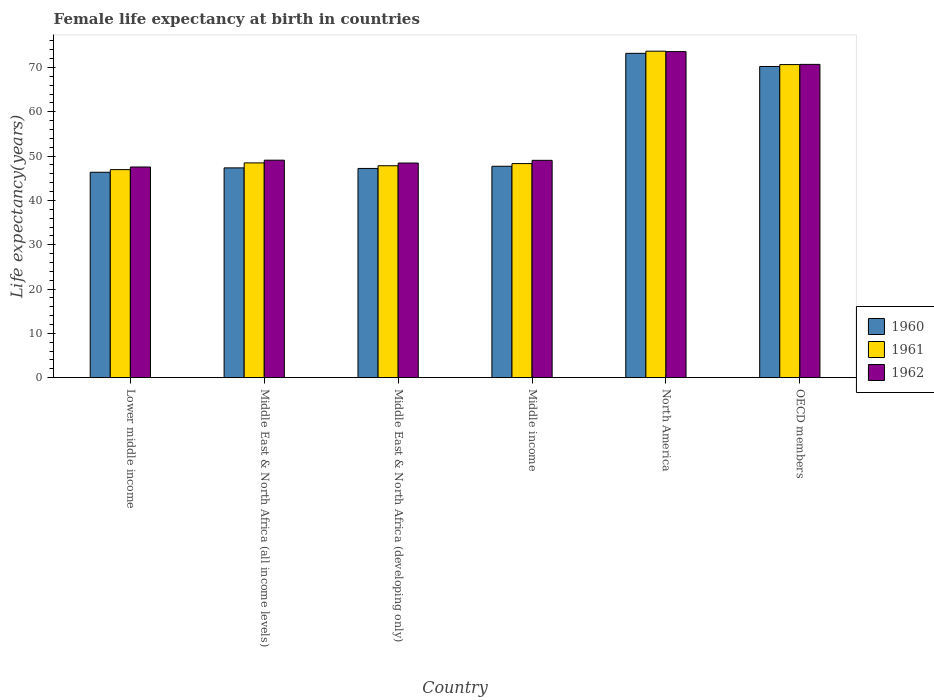How many different coloured bars are there?
Ensure brevity in your answer.  3. How many bars are there on the 3rd tick from the left?
Ensure brevity in your answer.  3. What is the female life expectancy at birth in 1960 in Middle income?
Provide a succinct answer. 47.7. Across all countries, what is the maximum female life expectancy at birth in 1962?
Provide a succinct answer. 73.58. Across all countries, what is the minimum female life expectancy at birth in 1961?
Offer a very short reply. 46.95. In which country was the female life expectancy at birth in 1960 maximum?
Your answer should be compact. North America. In which country was the female life expectancy at birth in 1960 minimum?
Provide a short and direct response. Lower middle income. What is the total female life expectancy at birth in 1961 in the graph?
Ensure brevity in your answer.  335.88. What is the difference between the female life expectancy at birth in 1961 in Lower middle income and that in Middle East & North Africa (developing only)?
Offer a terse response. -0.87. What is the difference between the female life expectancy at birth in 1961 in Middle East & North Africa (developing only) and the female life expectancy at birth in 1960 in OECD members?
Provide a succinct answer. -22.41. What is the average female life expectancy at birth in 1961 per country?
Give a very brief answer. 55.98. What is the difference between the female life expectancy at birth of/in 1961 and female life expectancy at birth of/in 1960 in OECD members?
Ensure brevity in your answer.  0.42. In how many countries, is the female life expectancy at birth in 1962 greater than 70 years?
Your response must be concise. 2. What is the ratio of the female life expectancy at birth in 1961 in Middle East & North Africa (all income levels) to that in Middle East & North Africa (developing only)?
Keep it short and to the point. 1.01. Is the difference between the female life expectancy at birth in 1961 in Middle East & North Africa (all income levels) and OECD members greater than the difference between the female life expectancy at birth in 1960 in Middle East & North Africa (all income levels) and OECD members?
Your answer should be very brief. Yes. What is the difference between the highest and the second highest female life expectancy at birth in 1961?
Your response must be concise. -25.21. What is the difference between the highest and the lowest female life expectancy at birth in 1960?
Make the answer very short. 26.84. Are all the bars in the graph horizontal?
Your answer should be very brief. No. Does the graph contain any zero values?
Your answer should be very brief. No. Does the graph contain grids?
Your answer should be very brief. No. How many legend labels are there?
Provide a short and direct response. 3. How are the legend labels stacked?
Provide a succinct answer. Vertical. What is the title of the graph?
Make the answer very short. Female life expectancy at birth in countries. What is the label or title of the Y-axis?
Offer a very short reply. Life expectancy(years). What is the Life expectancy(years) of 1960 in Lower middle income?
Offer a terse response. 46.36. What is the Life expectancy(years) of 1961 in Lower middle income?
Give a very brief answer. 46.95. What is the Life expectancy(years) of 1962 in Lower middle income?
Ensure brevity in your answer.  47.54. What is the Life expectancy(years) of 1960 in Middle East & North Africa (all income levels)?
Ensure brevity in your answer.  47.34. What is the Life expectancy(years) in 1961 in Middle East & North Africa (all income levels)?
Your response must be concise. 48.47. What is the Life expectancy(years) of 1962 in Middle East & North Africa (all income levels)?
Provide a succinct answer. 49.08. What is the Life expectancy(years) in 1960 in Middle East & North Africa (developing only)?
Provide a short and direct response. 47.21. What is the Life expectancy(years) of 1961 in Middle East & North Africa (developing only)?
Make the answer very short. 47.82. What is the Life expectancy(years) in 1962 in Middle East & North Africa (developing only)?
Your answer should be compact. 48.44. What is the Life expectancy(years) in 1960 in Middle income?
Make the answer very short. 47.7. What is the Life expectancy(years) of 1961 in Middle income?
Give a very brief answer. 48.31. What is the Life expectancy(years) of 1962 in Middle income?
Your response must be concise. 49.05. What is the Life expectancy(years) in 1960 in North America?
Your answer should be very brief. 73.19. What is the Life expectancy(years) in 1961 in North America?
Your answer should be compact. 73.68. What is the Life expectancy(years) of 1962 in North America?
Your response must be concise. 73.58. What is the Life expectancy(years) in 1960 in OECD members?
Your answer should be very brief. 70.23. What is the Life expectancy(years) in 1961 in OECD members?
Offer a terse response. 70.65. What is the Life expectancy(years) of 1962 in OECD members?
Ensure brevity in your answer.  70.7. Across all countries, what is the maximum Life expectancy(years) in 1960?
Provide a succinct answer. 73.19. Across all countries, what is the maximum Life expectancy(years) of 1961?
Ensure brevity in your answer.  73.68. Across all countries, what is the maximum Life expectancy(years) of 1962?
Provide a short and direct response. 73.58. Across all countries, what is the minimum Life expectancy(years) in 1960?
Ensure brevity in your answer.  46.36. Across all countries, what is the minimum Life expectancy(years) of 1961?
Offer a very short reply. 46.95. Across all countries, what is the minimum Life expectancy(years) of 1962?
Your answer should be very brief. 47.54. What is the total Life expectancy(years) in 1960 in the graph?
Ensure brevity in your answer.  332.04. What is the total Life expectancy(years) in 1961 in the graph?
Ensure brevity in your answer.  335.88. What is the total Life expectancy(years) in 1962 in the graph?
Your response must be concise. 338.39. What is the difference between the Life expectancy(years) of 1960 in Lower middle income and that in Middle East & North Africa (all income levels)?
Offer a terse response. -0.99. What is the difference between the Life expectancy(years) in 1961 in Lower middle income and that in Middle East & North Africa (all income levels)?
Provide a short and direct response. -1.52. What is the difference between the Life expectancy(years) in 1962 in Lower middle income and that in Middle East & North Africa (all income levels)?
Your answer should be compact. -1.54. What is the difference between the Life expectancy(years) of 1960 in Lower middle income and that in Middle East & North Africa (developing only)?
Your answer should be compact. -0.86. What is the difference between the Life expectancy(years) of 1961 in Lower middle income and that in Middle East & North Africa (developing only)?
Provide a succinct answer. -0.88. What is the difference between the Life expectancy(years) in 1962 in Lower middle income and that in Middle East & North Africa (developing only)?
Give a very brief answer. -0.89. What is the difference between the Life expectancy(years) of 1960 in Lower middle income and that in Middle income?
Provide a short and direct response. -1.35. What is the difference between the Life expectancy(years) of 1961 in Lower middle income and that in Middle income?
Keep it short and to the point. -1.36. What is the difference between the Life expectancy(years) in 1962 in Lower middle income and that in Middle income?
Make the answer very short. -1.5. What is the difference between the Life expectancy(years) of 1960 in Lower middle income and that in North America?
Keep it short and to the point. -26.84. What is the difference between the Life expectancy(years) of 1961 in Lower middle income and that in North America?
Make the answer very short. -26.73. What is the difference between the Life expectancy(years) of 1962 in Lower middle income and that in North America?
Your response must be concise. -26.04. What is the difference between the Life expectancy(years) of 1960 in Lower middle income and that in OECD members?
Make the answer very short. -23.87. What is the difference between the Life expectancy(years) in 1961 in Lower middle income and that in OECD members?
Provide a succinct answer. -23.7. What is the difference between the Life expectancy(years) of 1962 in Lower middle income and that in OECD members?
Ensure brevity in your answer.  -23.16. What is the difference between the Life expectancy(years) in 1960 in Middle East & North Africa (all income levels) and that in Middle East & North Africa (developing only)?
Offer a very short reply. 0.13. What is the difference between the Life expectancy(years) of 1961 in Middle East & North Africa (all income levels) and that in Middle East & North Africa (developing only)?
Provide a short and direct response. 0.64. What is the difference between the Life expectancy(years) in 1962 in Middle East & North Africa (all income levels) and that in Middle East & North Africa (developing only)?
Offer a very short reply. 0.65. What is the difference between the Life expectancy(years) in 1960 in Middle East & North Africa (all income levels) and that in Middle income?
Ensure brevity in your answer.  -0.36. What is the difference between the Life expectancy(years) of 1961 in Middle East & North Africa (all income levels) and that in Middle income?
Offer a very short reply. 0.16. What is the difference between the Life expectancy(years) in 1962 in Middle East & North Africa (all income levels) and that in Middle income?
Provide a succinct answer. 0.03. What is the difference between the Life expectancy(years) in 1960 in Middle East & North Africa (all income levels) and that in North America?
Provide a succinct answer. -25.85. What is the difference between the Life expectancy(years) in 1961 in Middle East & North Africa (all income levels) and that in North America?
Offer a very short reply. -25.21. What is the difference between the Life expectancy(years) of 1962 in Middle East & North Africa (all income levels) and that in North America?
Your answer should be very brief. -24.5. What is the difference between the Life expectancy(years) in 1960 in Middle East & North Africa (all income levels) and that in OECD members?
Offer a very short reply. -22.89. What is the difference between the Life expectancy(years) in 1961 in Middle East & North Africa (all income levels) and that in OECD members?
Ensure brevity in your answer.  -22.18. What is the difference between the Life expectancy(years) in 1962 in Middle East & North Africa (all income levels) and that in OECD members?
Provide a succinct answer. -21.62. What is the difference between the Life expectancy(years) in 1960 in Middle East & North Africa (developing only) and that in Middle income?
Offer a terse response. -0.49. What is the difference between the Life expectancy(years) of 1961 in Middle East & North Africa (developing only) and that in Middle income?
Your answer should be very brief. -0.49. What is the difference between the Life expectancy(years) of 1962 in Middle East & North Africa (developing only) and that in Middle income?
Make the answer very short. -0.61. What is the difference between the Life expectancy(years) of 1960 in Middle East & North Africa (developing only) and that in North America?
Provide a short and direct response. -25.98. What is the difference between the Life expectancy(years) in 1961 in Middle East & North Africa (developing only) and that in North America?
Offer a terse response. -25.85. What is the difference between the Life expectancy(years) of 1962 in Middle East & North Africa (developing only) and that in North America?
Provide a short and direct response. -25.15. What is the difference between the Life expectancy(years) in 1960 in Middle East & North Africa (developing only) and that in OECD members?
Give a very brief answer. -23.01. What is the difference between the Life expectancy(years) in 1961 in Middle East & North Africa (developing only) and that in OECD members?
Provide a short and direct response. -22.83. What is the difference between the Life expectancy(years) of 1962 in Middle East & North Africa (developing only) and that in OECD members?
Keep it short and to the point. -22.26. What is the difference between the Life expectancy(years) of 1960 in Middle income and that in North America?
Your response must be concise. -25.49. What is the difference between the Life expectancy(years) in 1961 in Middle income and that in North America?
Keep it short and to the point. -25.36. What is the difference between the Life expectancy(years) in 1962 in Middle income and that in North America?
Give a very brief answer. -24.54. What is the difference between the Life expectancy(years) in 1960 in Middle income and that in OECD members?
Your response must be concise. -22.52. What is the difference between the Life expectancy(years) of 1961 in Middle income and that in OECD members?
Your answer should be compact. -22.34. What is the difference between the Life expectancy(years) of 1962 in Middle income and that in OECD members?
Your answer should be compact. -21.65. What is the difference between the Life expectancy(years) in 1960 in North America and that in OECD members?
Ensure brevity in your answer.  2.96. What is the difference between the Life expectancy(years) of 1961 in North America and that in OECD members?
Provide a succinct answer. 3.02. What is the difference between the Life expectancy(years) in 1962 in North America and that in OECD members?
Ensure brevity in your answer.  2.88. What is the difference between the Life expectancy(years) in 1960 in Lower middle income and the Life expectancy(years) in 1961 in Middle East & North Africa (all income levels)?
Provide a succinct answer. -2.11. What is the difference between the Life expectancy(years) of 1960 in Lower middle income and the Life expectancy(years) of 1962 in Middle East & North Africa (all income levels)?
Offer a very short reply. -2.73. What is the difference between the Life expectancy(years) of 1961 in Lower middle income and the Life expectancy(years) of 1962 in Middle East & North Africa (all income levels)?
Offer a very short reply. -2.13. What is the difference between the Life expectancy(years) of 1960 in Lower middle income and the Life expectancy(years) of 1961 in Middle East & North Africa (developing only)?
Your answer should be very brief. -1.47. What is the difference between the Life expectancy(years) of 1960 in Lower middle income and the Life expectancy(years) of 1962 in Middle East & North Africa (developing only)?
Provide a succinct answer. -2.08. What is the difference between the Life expectancy(years) of 1961 in Lower middle income and the Life expectancy(years) of 1962 in Middle East & North Africa (developing only)?
Provide a short and direct response. -1.49. What is the difference between the Life expectancy(years) in 1960 in Lower middle income and the Life expectancy(years) in 1961 in Middle income?
Provide a succinct answer. -1.96. What is the difference between the Life expectancy(years) in 1960 in Lower middle income and the Life expectancy(years) in 1962 in Middle income?
Give a very brief answer. -2.69. What is the difference between the Life expectancy(years) in 1961 in Lower middle income and the Life expectancy(years) in 1962 in Middle income?
Provide a short and direct response. -2.1. What is the difference between the Life expectancy(years) in 1960 in Lower middle income and the Life expectancy(years) in 1961 in North America?
Your response must be concise. -27.32. What is the difference between the Life expectancy(years) of 1960 in Lower middle income and the Life expectancy(years) of 1962 in North America?
Give a very brief answer. -27.23. What is the difference between the Life expectancy(years) in 1961 in Lower middle income and the Life expectancy(years) in 1962 in North America?
Offer a terse response. -26.63. What is the difference between the Life expectancy(years) of 1960 in Lower middle income and the Life expectancy(years) of 1961 in OECD members?
Provide a short and direct response. -24.3. What is the difference between the Life expectancy(years) in 1960 in Lower middle income and the Life expectancy(years) in 1962 in OECD members?
Make the answer very short. -24.35. What is the difference between the Life expectancy(years) of 1961 in Lower middle income and the Life expectancy(years) of 1962 in OECD members?
Provide a short and direct response. -23.75. What is the difference between the Life expectancy(years) in 1960 in Middle East & North Africa (all income levels) and the Life expectancy(years) in 1961 in Middle East & North Africa (developing only)?
Provide a short and direct response. -0.48. What is the difference between the Life expectancy(years) of 1960 in Middle East & North Africa (all income levels) and the Life expectancy(years) of 1962 in Middle East & North Africa (developing only)?
Your answer should be very brief. -1.09. What is the difference between the Life expectancy(years) in 1961 in Middle East & North Africa (all income levels) and the Life expectancy(years) in 1962 in Middle East & North Africa (developing only)?
Give a very brief answer. 0.03. What is the difference between the Life expectancy(years) in 1960 in Middle East & North Africa (all income levels) and the Life expectancy(years) in 1961 in Middle income?
Your response must be concise. -0.97. What is the difference between the Life expectancy(years) in 1960 in Middle East & North Africa (all income levels) and the Life expectancy(years) in 1962 in Middle income?
Your answer should be compact. -1.7. What is the difference between the Life expectancy(years) of 1961 in Middle East & North Africa (all income levels) and the Life expectancy(years) of 1962 in Middle income?
Your response must be concise. -0.58. What is the difference between the Life expectancy(years) of 1960 in Middle East & North Africa (all income levels) and the Life expectancy(years) of 1961 in North America?
Provide a succinct answer. -26.33. What is the difference between the Life expectancy(years) in 1960 in Middle East & North Africa (all income levels) and the Life expectancy(years) in 1962 in North America?
Your answer should be compact. -26.24. What is the difference between the Life expectancy(years) in 1961 in Middle East & North Africa (all income levels) and the Life expectancy(years) in 1962 in North America?
Ensure brevity in your answer.  -25.11. What is the difference between the Life expectancy(years) of 1960 in Middle East & North Africa (all income levels) and the Life expectancy(years) of 1961 in OECD members?
Your response must be concise. -23.31. What is the difference between the Life expectancy(years) in 1960 in Middle East & North Africa (all income levels) and the Life expectancy(years) in 1962 in OECD members?
Keep it short and to the point. -23.36. What is the difference between the Life expectancy(years) of 1961 in Middle East & North Africa (all income levels) and the Life expectancy(years) of 1962 in OECD members?
Provide a short and direct response. -22.23. What is the difference between the Life expectancy(years) in 1960 in Middle East & North Africa (developing only) and the Life expectancy(years) in 1961 in Middle income?
Ensure brevity in your answer.  -1.1. What is the difference between the Life expectancy(years) in 1960 in Middle East & North Africa (developing only) and the Life expectancy(years) in 1962 in Middle income?
Your answer should be compact. -1.83. What is the difference between the Life expectancy(years) in 1961 in Middle East & North Africa (developing only) and the Life expectancy(years) in 1962 in Middle income?
Your response must be concise. -1.22. What is the difference between the Life expectancy(years) of 1960 in Middle East & North Africa (developing only) and the Life expectancy(years) of 1961 in North America?
Keep it short and to the point. -26.46. What is the difference between the Life expectancy(years) in 1960 in Middle East & North Africa (developing only) and the Life expectancy(years) in 1962 in North America?
Make the answer very short. -26.37. What is the difference between the Life expectancy(years) of 1961 in Middle East & North Africa (developing only) and the Life expectancy(years) of 1962 in North America?
Ensure brevity in your answer.  -25.76. What is the difference between the Life expectancy(years) in 1960 in Middle East & North Africa (developing only) and the Life expectancy(years) in 1961 in OECD members?
Ensure brevity in your answer.  -23.44. What is the difference between the Life expectancy(years) in 1960 in Middle East & North Africa (developing only) and the Life expectancy(years) in 1962 in OECD members?
Keep it short and to the point. -23.49. What is the difference between the Life expectancy(years) in 1961 in Middle East & North Africa (developing only) and the Life expectancy(years) in 1962 in OECD members?
Your answer should be compact. -22.88. What is the difference between the Life expectancy(years) in 1960 in Middle income and the Life expectancy(years) in 1961 in North America?
Your response must be concise. -25.97. What is the difference between the Life expectancy(years) in 1960 in Middle income and the Life expectancy(years) in 1962 in North America?
Provide a succinct answer. -25.88. What is the difference between the Life expectancy(years) in 1961 in Middle income and the Life expectancy(years) in 1962 in North America?
Provide a short and direct response. -25.27. What is the difference between the Life expectancy(years) of 1960 in Middle income and the Life expectancy(years) of 1961 in OECD members?
Your answer should be compact. -22.95. What is the difference between the Life expectancy(years) in 1960 in Middle income and the Life expectancy(years) in 1962 in OECD members?
Your answer should be very brief. -23. What is the difference between the Life expectancy(years) of 1961 in Middle income and the Life expectancy(years) of 1962 in OECD members?
Make the answer very short. -22.39. What is the difference between the Life expectancy(years) of 1960 in North America and the Life expectancy(years) of 1961 in OECD members?
Your answer should be very brief. 2.54. What is the difference between the Life expectancy(years) in 1960 in North America and the Life expectancy(years) in 1962 in OECD members?
Provide a succinct answer. 2.49. What is the difference between the Life expectancy(years) in 1961 in North America and the Life expectancy(years) in 1962 in OECD members?
Keep it short and to the point. 2.98. What is the average Life expectancy(years) in 1960 per country?
Ensure brevity in your answer.  55.34. What is the average Life expectancy(years) in 1961 per country?
Offer a very short reply. 55.98. What is the average Life expectancy(years) in 1962 per country?
Give a very brief answer. 56.4. What is the difference between the Life expectancy(years) of 1960 and Life expectancy(years) of 1961 in Lower middle income?
Your answer should be very brief. -0.59. What is the difference between the Life expectancy(years) in 1960 and Life expectancy(years) in 1962 in Lower middle income?
Your answer should be very brief. -1.19. What is the difference between the Life expectancy(years) of 1961 and Life expectancy(years) of 1962 in Lower middle income?
Provide a short and direct response. -0.59. What is the difference between the Life expectancy(years) of 1960 and Life expectancy(years) of 1961 in Middle East & North Africa (all income levels)?
Your response must be concise. -1.13. What is the difference between the Life expectancy(years) in 1960 and Life expectancy(years) in 1962 in Middle East & North Africa (all income levels)?
Give a very brief answer. -1.74. What is the difference between the Life expectancy(years) of 1961 and Life expectancy(years) of 1962 in Middle East & North Africa (all income levels)?
Keep it short and to the point. -0.61. What is the difference between the Life expectancy(years) of 1960 and Life expectancy(years) of 1961 in Middle East & North Africa (developing only)?
Your answer should be compact. -0.61. What is the difference between the Life expectancy(years) of 1960 and Life expectancy(years) of 1962 in Middle East & North Africa (developing only)?
Offer a terse response. -1.22. What is the difference between the Life expectancy(years) in 1961 and Life expectancy(years) in 1962 in Middle East & North Africa (developing only)?
Provide a succinct answer. -0.61. What is the difference between the Life expectancy(years) of 1960 and Life expectancy(years) of 1961 in Middle income?
Ensure brevity in your answer.  -0.61. What is the difference between the Life expectancy(years) in 1960 and Life expectancy(years) in 1962 in Middle income?
Give a very brief answer. -1.34. What is the difference between the Life expectancy(years) of 1961 and Life expectancy(years) of 1962 in Middle income?
Provide a short and direct response. -0.73. What is the difference between the Life expectancy(years) in 1960 and Life expectancy(years) in 1961 in North America?
Keep it short and to the point. -0.48. What is the difference between the Life expectancy(years) in 1960 and Life expectancy(years) in 1962 in North America?
Offer a terse response. -0.39. What is the difference between the Life expectancy(years) of 1961 and Life expectancy(years) of 1962 in North America?
Make the answer very short. 0.09. What is the difference between the Life expectancy(years) of 1960 and Life expectancy(years) of 1961 in OECD members?
Ensure brevity in your answer.  -0.42. What is the difference between the Life expectancy(years) in 1960 and Life expectancy(years) in 1962 in OECD members?
Keep it short and to the point. -0.47. What is the difference between the Life expectancy(years) of 1961 and Life expectancy(years) of 1962 in OECD members?
Offer a terse response. -0.05. What is the ratio of the Life expectancy(years) in 1960 in Lower middle income to that in Middle East & North Africa (all income levels)?
Give a very brief answer. 0.98. What is the ratio of the Life expectancy(years) in 1961 in Lower middle income to that in Middle East & North Africa (all income levels)?
Offer a very short reply. 0.97. What is the ratio of the Life expectancy(years) in 1962 in Lower middle income to that in Middle East & North Africa (all income levels)?
Your response must be concise. 0.97. What is the ratio of the Life expectancy(years) of 1960 in Lower middle income to that in Middle East & North Africa (developing only)?
Keep it short and to the point. 0.98. What is the ratio of the Life expectancy(years) in 1961 in Lower middle income to that in Middle East & North Africa (developing only)?
Offer a terse response. 0.98. What is the ratio of the Life expectancy(years) of 1962 in Lower middle income to that in Middle East & North Africa (developing only)?
Give a very brief answer. 0.98. What is the ratio of the Life expectancy(years) of 1960 in Lower middle income to that in Middle income?
Ensure brevity in your answer.  0.97. What is the ratio of the Life expectancy(years) in 1961 in Lower middle income to that in Middle income?
Offer a terse response. 0.97. What is the ratio of the Life expectancy(years) in 1962 in Lower middle income to that in Middle income?
Provide a short and direct response. 0.97. What is the ratio of the Life expectancy(years) in 1960 in Lower middle income to that in North America?
Your response must be concise. 0.63. What is the ratio of the Life expectancy(years) in 1961 in Lower middle income to that in North America?
Provide a short and direct response. 0.64. What is the ratio of the Life expectancy(years) of 1962 in Lower middle income to that in North America?
Your answer should be compact. 0.65. What is the ratio of the Life expectancy(years) in 1960 in Lower middle income to that in OECD members?
Give a very brief answer. 0.66. What is the ratio of the Life expectancy(years) of 1961 in Lower middle income to that in OECD members?
Make the answer very short. 0.66. What is the ratio of the Life expectancy(years) of 1962 in Lower middle income to that in OECD members?
Your answer should be very brief. 0.67. What is the ratio of the Life expectancy(years) of 1961 in Middle East & North Africa (all income levels) to that in Middle East & North Africa (developing only)?
Your response must be concise. 1.01. What is the ratio of the Life expectancy(years) of 1962 in Middle East & North Africa (all income levels) to that in Middle East & North Africa (developing only)?
Offer a terse response. 1.01. What is the ratio of the Life expectancy(years) in 1960 in Middle East & North Africa (all income levels) to that in Middle income?
Ensure brevity in your answer.  0.99. What is the ratio of the Life expectancy(years) in 1961 in Middle East & North Africa (all income levels) to that in Middle income?
Your response must be concise. 1. What is the ratio of the Life expectancy(years) of 1960 in Middle East & North Africa (all income levels) to that in North America?
Ensure brevity in your answer.  0.65. What is the ratio of the Life expectancy(years) in 1961 in Middle East & North Africa (all income levels) to that in North America?
Keep it short and to the point. 0.66. What is the ratio of the Life expectancy(years) of 1962 in Middle East & North Africa (all income levels) to that in North America?
Ensure brevity in your answer.  0.67. What is the ratio of the Life expectancy(years) in 1960 in Middle East & North Africa (all income levels) to that in OECD members?
Make the answer very short. 0.67. What is the ratio of the Life expectancy(years) in 1961 in Middle East & North Africa (all income levels) to that in OECD members?
Your answer should be very brief. 0.69. What is the ratio of the Life expectancy(years) of 1962 in Middle East & North Africa (all income levels) to that in OECD members?
Offer a terse response. 0.69. What is the ratio of the Life expectancy(years) of 1962 in Middle East & North Africa (developing only) to that in Middle income?
Your answer should be compact. 0.99. What is the ratio of the Life expectancy(years) of 1960 in Middle East & North Africa (developing only) to that in North America?
Make the answer very short. 0.65. What is the ratio of the Life expectancy(years) in 1961 in Middle East & North Africa (developing only) to that in North America?
Offer a terse response. 0.65. What is the ratio of the Life expectancy(years) of 1962 in Middle East & North Africa (developing only) to that in North America?
Offer a terse response. 0.66. What is the ratio of the Life expectancy(years) of 1960 in Middle East & North Africa (developing only) to that in OECD members?
Your answer should be compact. 0.67. What is the ratio of the Life expectancy(years) of 1961 in Middle East & North Africa (developing only) to that in OECD members?
Provide a short and direct response. 0.68. What is the ratio of the Life expectancy(years) in 1962 in Middle East & North Africa (developing only) to that in OECD members?
Ensure brevity in your answer.  0.69. What is the ratio of the Life expectancy(years) of 1960 in Middle income to that in North America?
Offer a terse response. 0.65. What is the ratio of the Life expectancy(years) in 1961 in Middle income to that in North America?
Keep it short and to the point. 0.66. What is the ratio of the Life expectancy(years) in 1962 in Middle income to that in North America?
Ensure brevity in your answer.  0.67. What is the ratio of the Life expectancy(years) of 1960 in Middle income to that in OECD members?
Your answer should be compact. 0.68. What is the ratio of the Life expectancy(years) of 1961 in Middle income to that in OECD members?
Provide a short and direct response. 0.68. What is the ratio of the Life expectancy(years) of 1962 in Middle income to that in OECD members?
Give a very brief answer. 0.69. What is the ratio of the Life expectancy(years) of 1960 in North America to that in OECD members?
Make the answer very short. 1.04. What is the ratio of the Life expectancy(years) of 1961 in North America to that in OECD members?
Keep it short and to the point. 1.04. What is the ratio of the Life expectancy(years) in 1962 in North America to that in OECD members?
Make the answer very short. 1.04. What is the difference between the highest and the second highest Life expectancy(years) in 1960?
Offer a very short reply. 2.96. What is the difference between the highest and the second highest Life expectancy(years) in 1961?
Your answer should be very brief. 3.02. What is the difference between the highest and the second highest Life expectancy(years) of 1962?
Keep it short and to the point. 2.88. What is the difference between the highest and the lowest Life expectancy(years) in 1960?
Ensure brevity in your answer.  26.84. What is the difference between the highest and the lowest Life expectancy(years) in 1961?
Provide a succinct answer. 26.73. What is the difference between the highest and the lowest Life expectancy(years) of 1962?
Your answer should be compact. 26.04. 